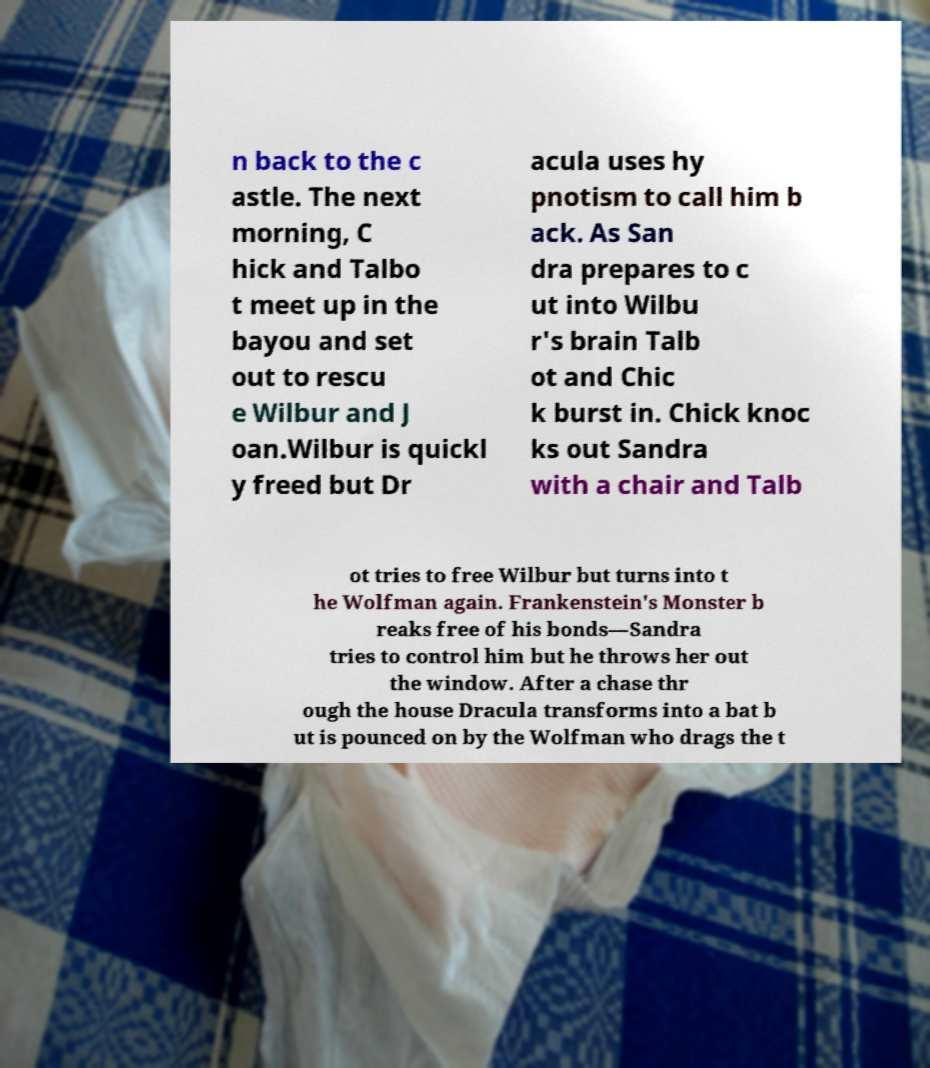What messages or text are displayed in this image? I need them in a readable, typed format. n back to the c astle. The next morning, C hick and Talbo t meet up in the bayou and set out to rescu e Wilbur and J oan.Wilbur is quickl y freed but Dr acula uses hy pnotism to call him b ack. As San dra prepares to c ut into Wilbu r's brain Talb ot and Chic k burst in. Chick knoc ks out Sandra with a chair and Talb ot tries to free Wilbur but turns into t he Wolfman again. Frankenstein's Monster b reaks free of his bonds—Sandra tries to control him but he throws her out the window. After a chase thr ough the house Dracula transforms into a bat b ut is pounced on by the Wolfman who drags the t 